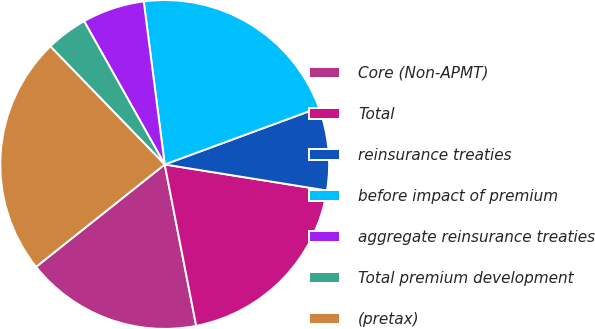<chart> <loc_0><loc_0><loc_500><loc_500><pie_chart><fcel>Core (Non-APMT)<fcel>Total<fcel>reinsurance treaties<fcel>before impact of premium<fcel>aggregate reinsurance treaties<fcel>Total premium development<fcel>(pretax)<nl><fcel>17.37%<fcel>19.4%<fcel>8.15%<fcel>21.42%<fcel>6.12%<fcel>4.09%<fcel>23.45%<nl></chart> 